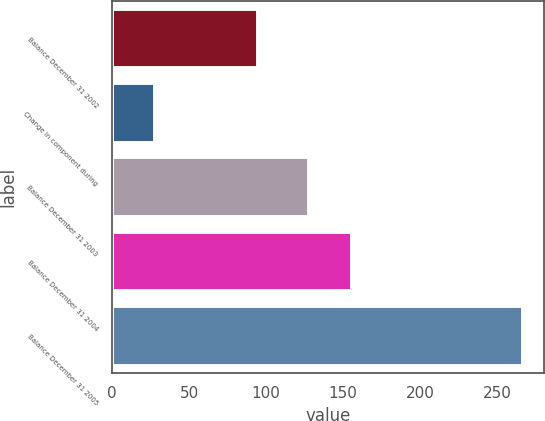Convert chart. <chart><loc_0><loc_0><loc_500><loc_500><bar_chart><fcel>Balance December 31 2002<fcel>Change in component during<fcel>Balance December 31 2003<fcel>Balance December 31 2004<fcel>Balance December 31 2005<nl><fcel>95<fcel>28<fcel>128<fcel>156<fcel>267<nl></chart> 